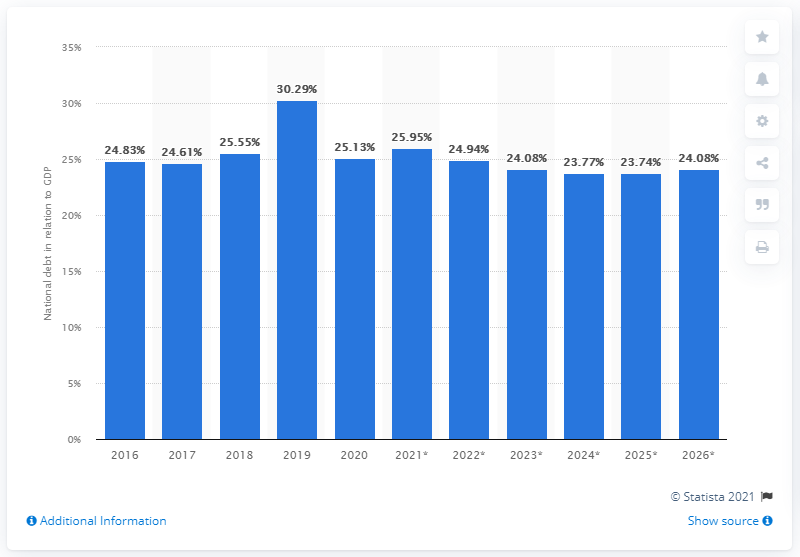Give some essential details in this illustration. In 2020, the national debt of Haiti accounted for approximately 24.94% of the country's Gross Domestic Product (GDP). In 2020, the national debt of Haiti came to an end. 